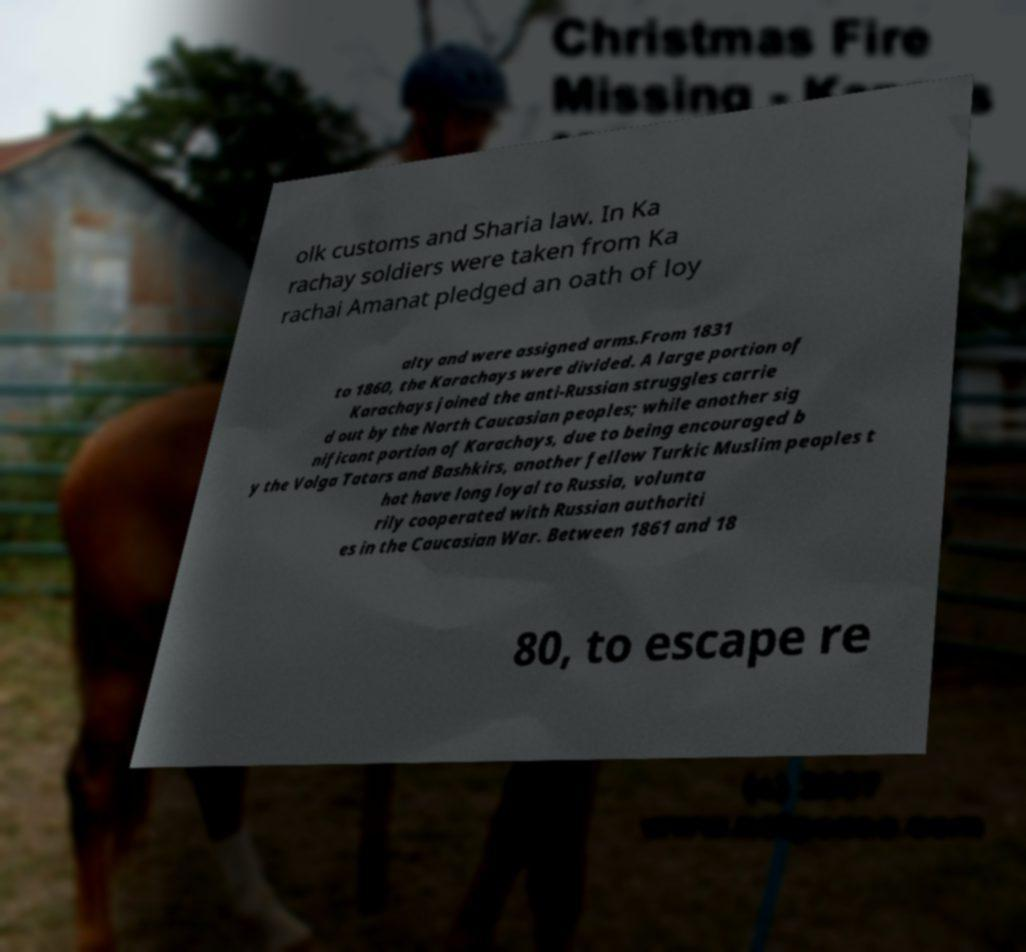Could you extract and type out the text from this image? olk customs and Sharia law. In Ka rachay soldiers were taken from Ka rachai Amanat pledged an oath of loy alty and were assigned arms.From 1831 to 1860, the Karachays were divided. A large portion of Karachays joined the anti-Russian struggles carrie d out by the North Caucasian peoples; while another sig nificant portion of Karachays, due to being encouraged b y the Volga Tatars and Bashkirs, another fellow Turkic Muslim peoples t hat have long loyal to Russia, volunta rily cooperated with Russian authoriti es in the Caucasian War. Between 1861 and 18 80, to escape re 